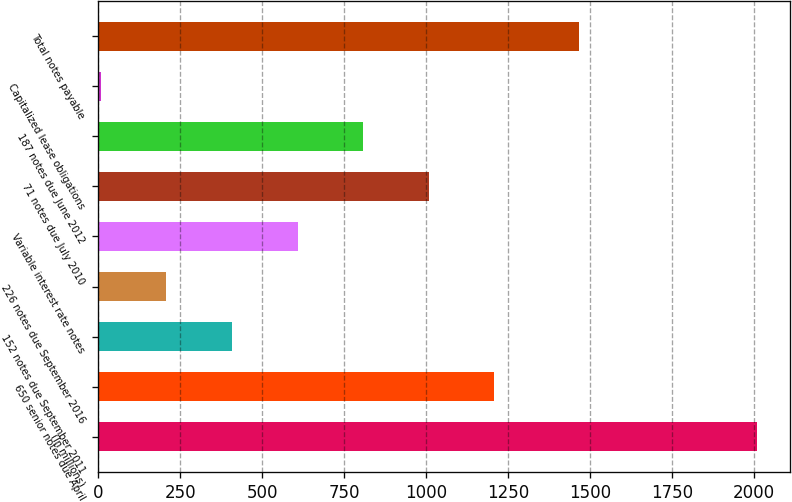Convert chart to OTSL. <chart><loc_0><loc_0><loc_500><loc_500><bar_chart><fcel>(In millions)<fcel>650 senior notes due April<fcel>152 notes due September 2011<fcel>226 notes due September 2016<fcel>Variable interest rate notes<fcel>71 notes due July 2010<fcel>187 notes due June 2012<fcel>Capitalized lease obligations<fcel>Total notes payable<nl><fcel>2007<fcel>1207.4<fcel>407.8<fcel>207.9<fcel>607.7<fcel>1007.5<fcel>807.6<fcel>8<fcel>1465<nl></chart> 